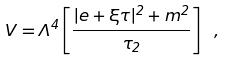<formula> <loc_0><loc_0><loc_500><loc_500>V = \Lambda ^ { 4 } \left [ { \frac { | e + \xi \tau | ^ { 2 } + m ^ { 2 } } { \tau _ { 2 } } } \right ] \ ,</formula> 